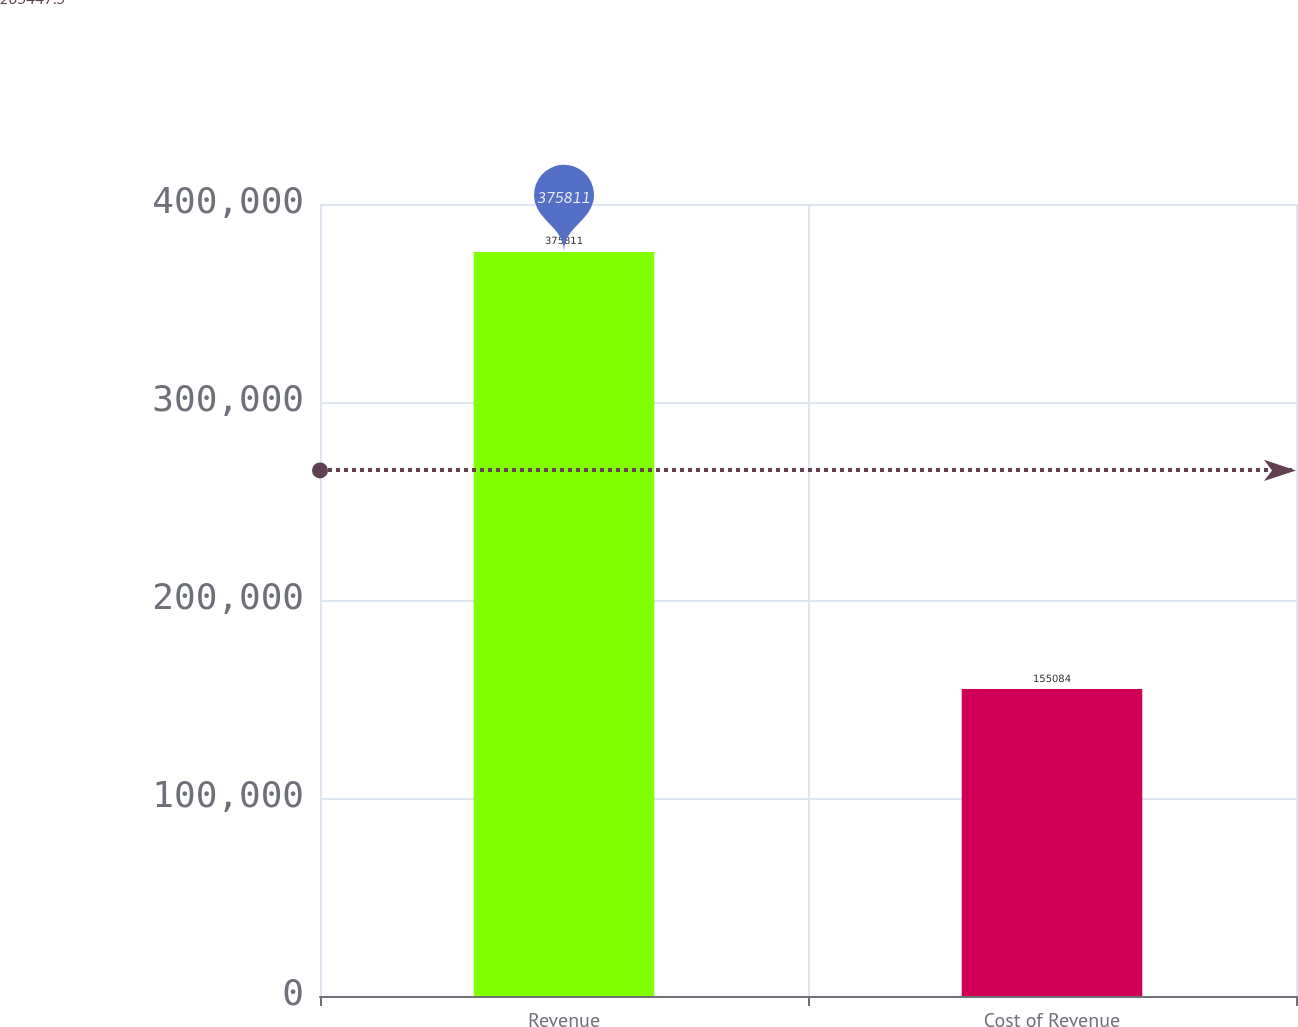Convert chart to OTSL. <chart><loc_0><loc_0><loc_500><loc_500><bar_chart><fcel>Revenue<fcel>Cost of Revenue<nl><fcel>375811<fcel>155084<nl></chart> 